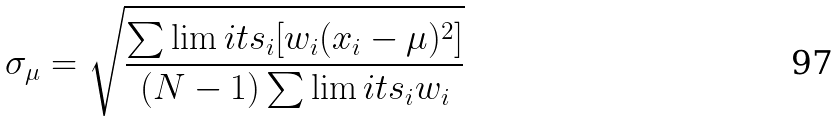Convert formula to latex. <formula><loc_0><loc_0><loc_500><loc_500>\sigma _ { \mu } = \sqrt { \frac { \sum \lim i t s _ { i } [ w _ { i } ( x _ { i } - \mu ) ^ { 2 } ] } { ( N - 1 ) \sum \lim i t s _ { i } w _ { i } } }</formula> 